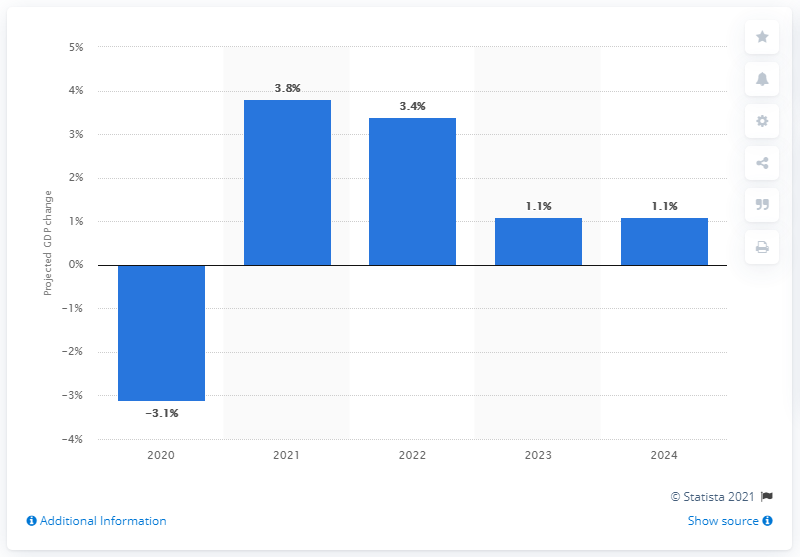Mention a couple of crucial points in this snapshot. The GDP forecast predicts a growth rate of 1.1% in 2023 and 2024. According to projections, Norway's Gross Domestic Product is expected to grow by 3.8% in 2021. 